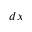Convert formula to latex. <formula><loc_0><loc_0><loc_500><loc_500>d x</formula> 